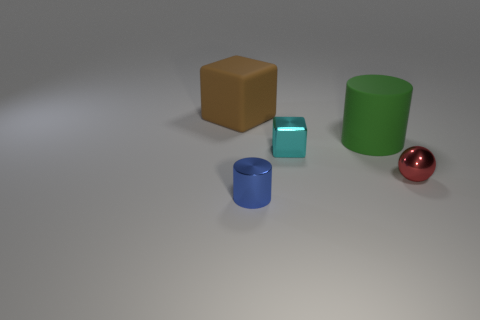What number of big things are blocks or green things? In the image, there are a total of three large objects: one brown block, one green cylinder, and one red sphere. If we consider both criteria – being a block or being green – there are two objects that meet this description: the brown block and the green cylinder. 